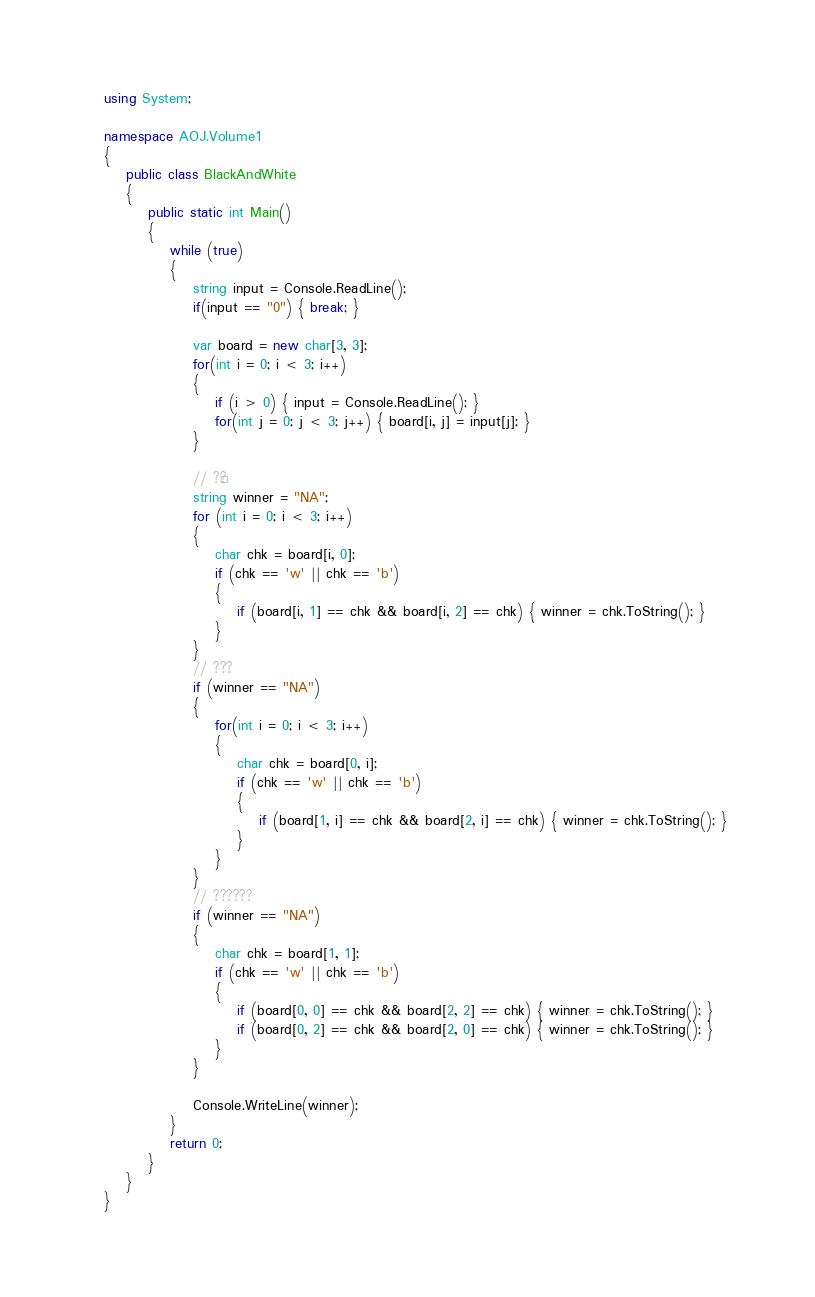Convert code to text. <code><loc_0><loc_0><loc_500><loc_500><_C#_>using System;

namespace AOJ.Volume1
{
    public class BlackAndWhite
    {
        public static int Main()
        {
            while (true)
            {
                string input = Console.ReadLine();
                if(input == "0") { break; }

                var board = new char[3, 3];
                for(int i = 0; i < 3; i++)
                {
                    if (i > 0) { input = Console.ReadLine(); }
                    for(int j = 0; j < 3; j++) { board[i, j] = input[j]; }
                }

                // ?¨?
                string winner = "NA";
                for (int i = 0; i < 3; i++)
                {
                    char chk = board[i, 0];
                    if (chk == 'w' || chk == 'b')
                    {
                        if (board[i, 1] == chk && board[i, 2] == chk) { winner = chk.ToString(); }
                    }
                }
                // ???
                if (winner == "NA")
                {
                    for(int i = 0; i < 3; i++)
                    {
                        char chk = board[0, i];
                        if (chk == 'w' || chk == 'b')
                        {
                            if (board[1, i] == chk && board[2, i] == chk) { winner = chk.ToString(); }
                        }
                    }
                }
                // ??????
                if (winner == "NA")
                {
                    char chk = board[1, 1];
                    if (chk == 'w' || chk == 'b')
                    {
                        if (board[0, 0] == chk && board[2, 2] == chk) { winner = chk.ToString(); }
                        if (board[0, 2] == chk && board[2, 0] == chk) { winner = chk.ToString(); }
                    }
                }

                Console.WriteLine(winner);
            }
            return 0;
        }
    }
}</code> 